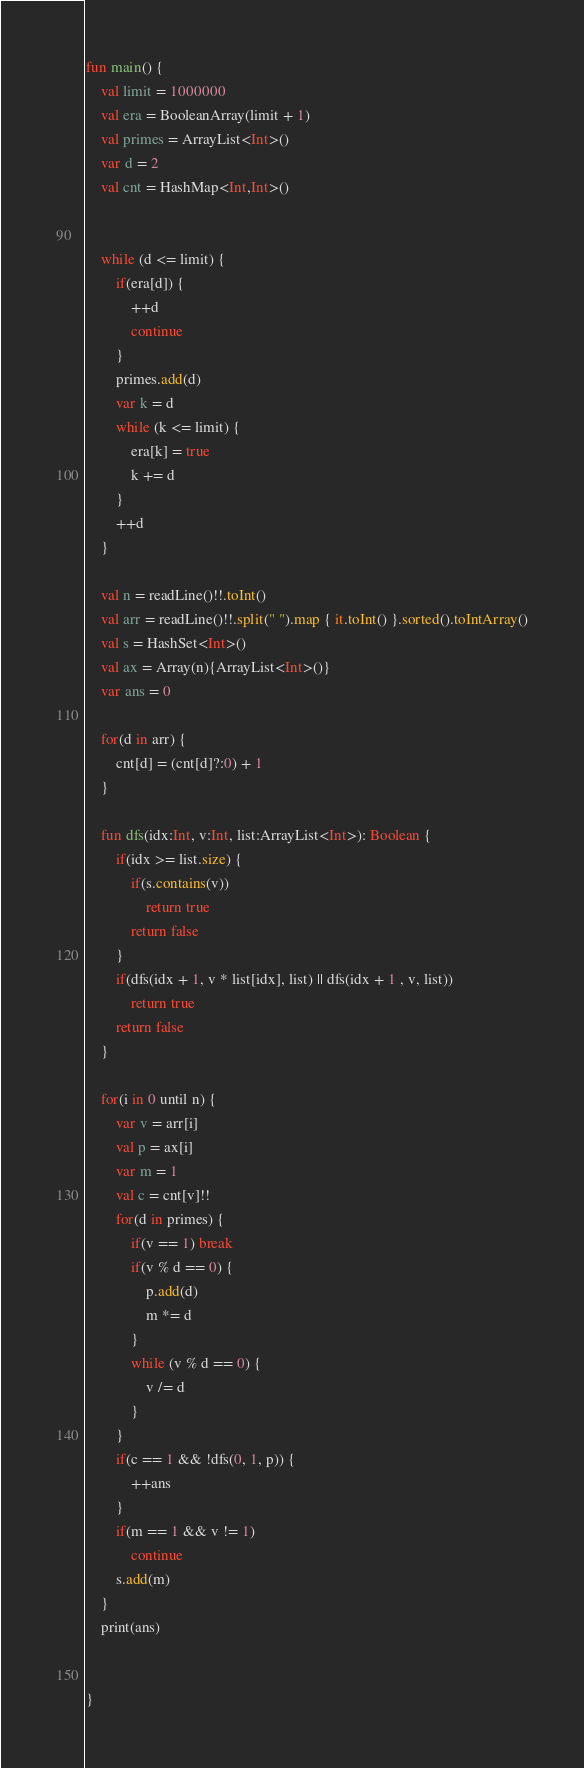<code> <loc_0><loc_0><loc_500><loc_500><_Kotlin_>

fun main() {
    val limit = 1000000
    val era = BooleanArray(limit + 1)
    val primes = ArrayList<Int>()
    var d = 2
    val cnt = HashMap<Int,Int>()


    while (d <= limit) {
        if(era[d]) {
            ++d
            continue
        }
        primes.add(d)
        var k = d
        while (k <= limit) {
            era[k] = true
            k += d
        }
        ++d
    }

    val n = readLine()!!.toInt()
    val arr = readLine()!!.split(" ").map { it.toInt() }.sorted().toIntArray()
    val s = HashSet<Int>()
    val ax = Array(n){ArrayList<Int>()}
    var ans = 0

    for(d in arr) {
        cnt[d] = (cnt[d]?:0) + 1
    }

    fun dfs(idx:Int, v:Int, list:ArrayList<Int>): Boolean {
        if(idx >= list.size) {
            if(s.contains(v))
                return true
            return false
        }
        if(dfs(idx + 1, v * list[idx], list) || dfs(idx + 1 , v, list))
            return true
        return false
    }

    for(i in 0 until n) {
        var v = arr[i]
        val p = ax[i]
        var m = 1
        val c = cnt[v]!!
        for(d in primes) {
            if(v == 1) break
            if(v % d == 0) {
                p.add(d)
                m *= d
            }
            while (v % d == 0) {
                v /= d
            }
        }
        if(c == 1 && !dfs(0, 1, p)) {
            ++ans
        }
        if(m == 1 && v != 1)
            continue
        s.add(m)
    }
    print(ans)


}
</code> 